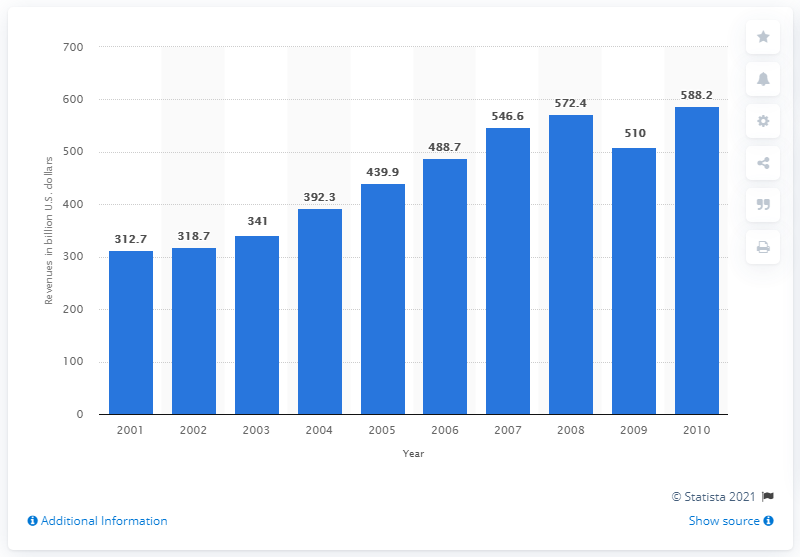Highlight a few significant elements in this photo. The revenues of the world's 150 leading airlines totaled approximately 510 billion US dollars in 2009. 